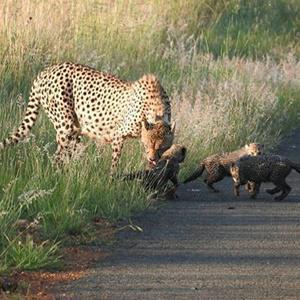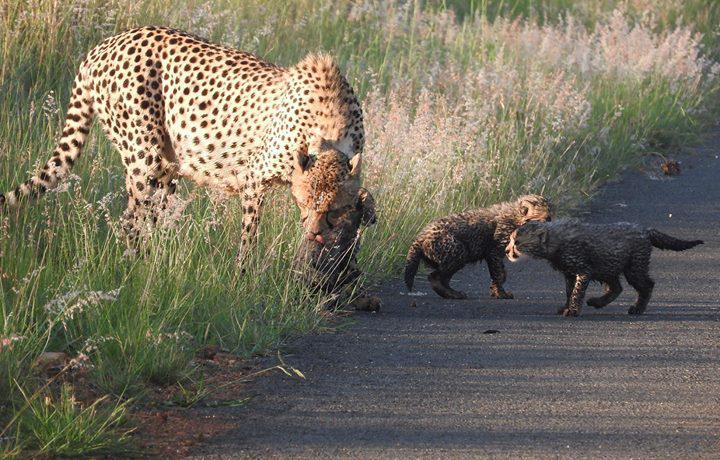The first image is the image on the left, the second image is the image on the right. Evaluate the accuracy of this statement regarding the images: "The left and right image contains the same number of cheetahs.". Is it true? Answer yes or no. Yes. The first image is the image on the left, the second image is the image on the right. For the images displayed, is the sentence "The right image contains a single cheetah." factually correct? Answer yes or no. No. 